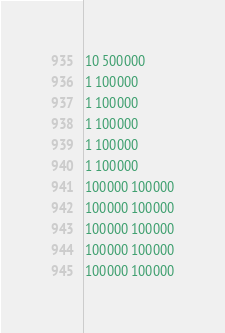<code> <loc_0><loc_0><loc_500><loc_500><_C_>10 500000
1 100000
1 100000
1 100000
1 100000
1 100000
100000 100000
100000 100000
100000 100000
100000 100000
100000 100000</code> 